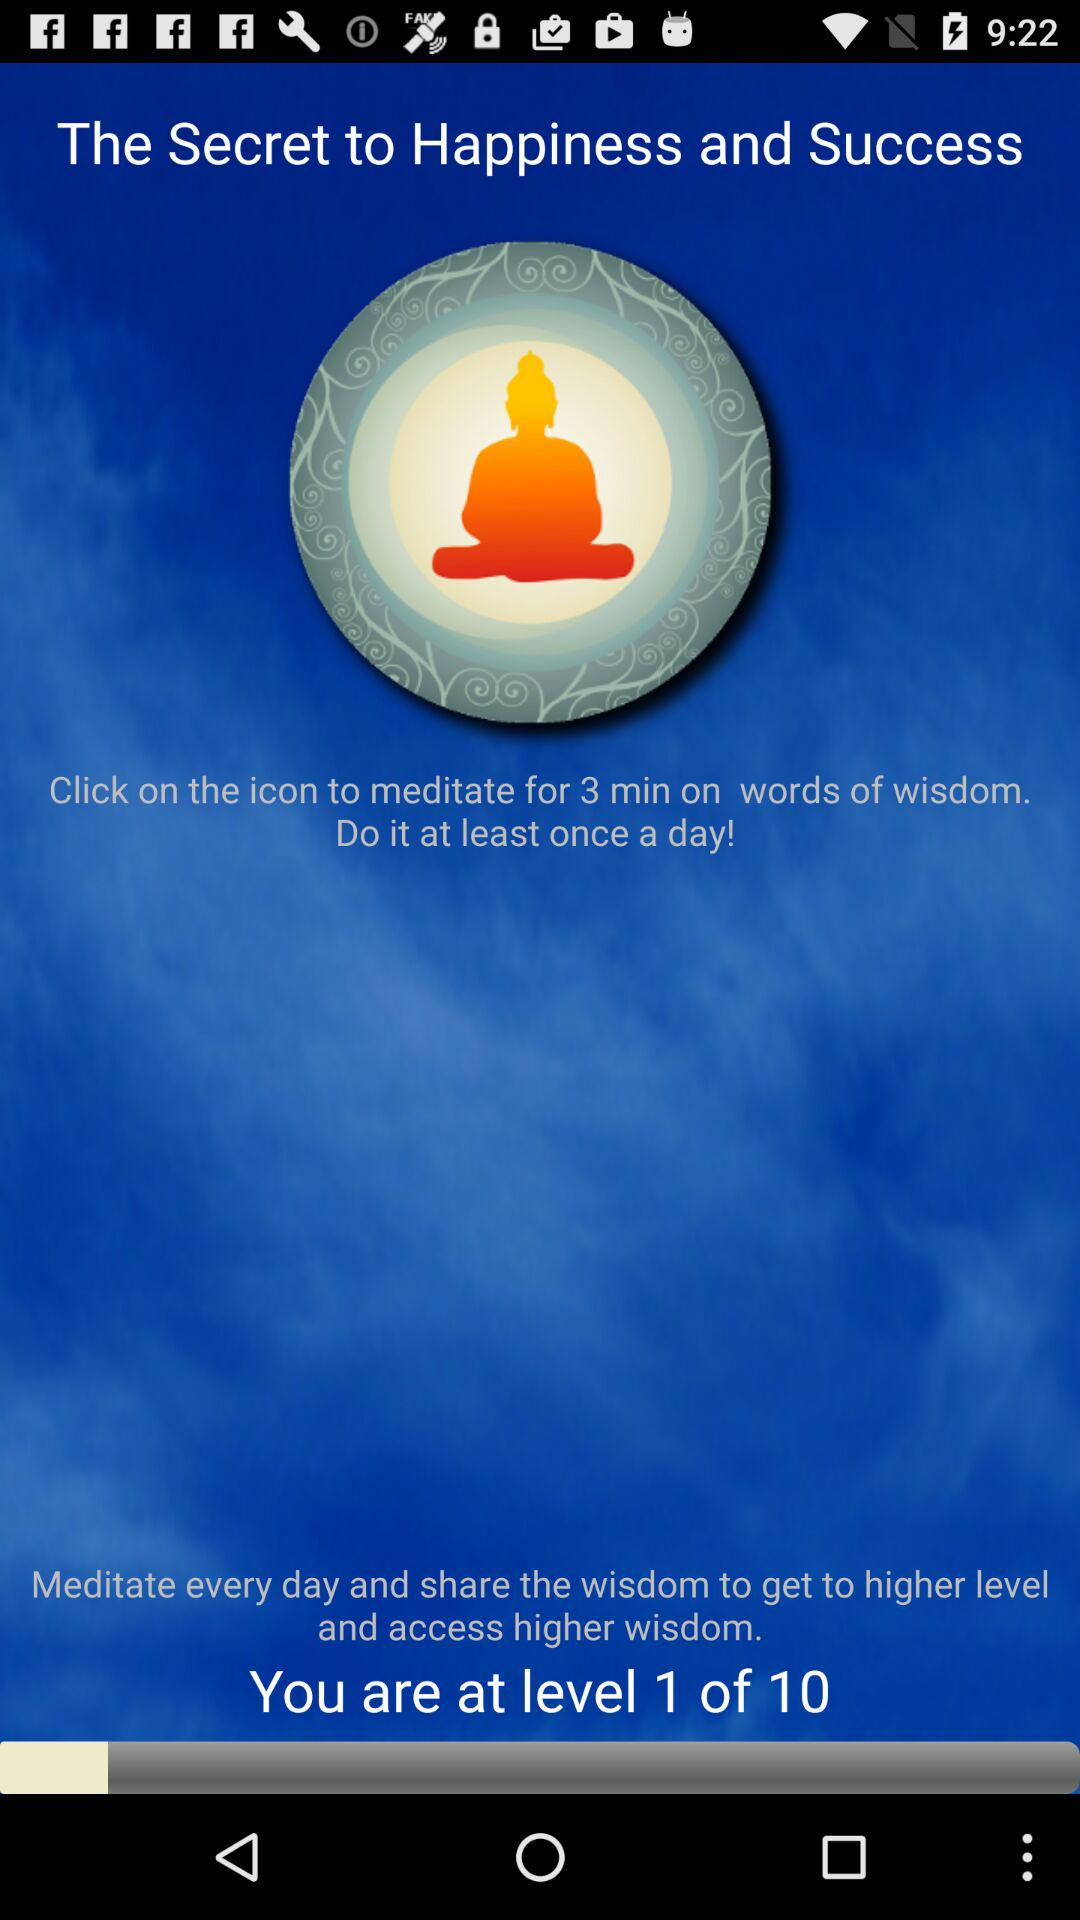How many more levels do you need to reach to get to the highest level?
Answer the question using a single word or phrase. 9 